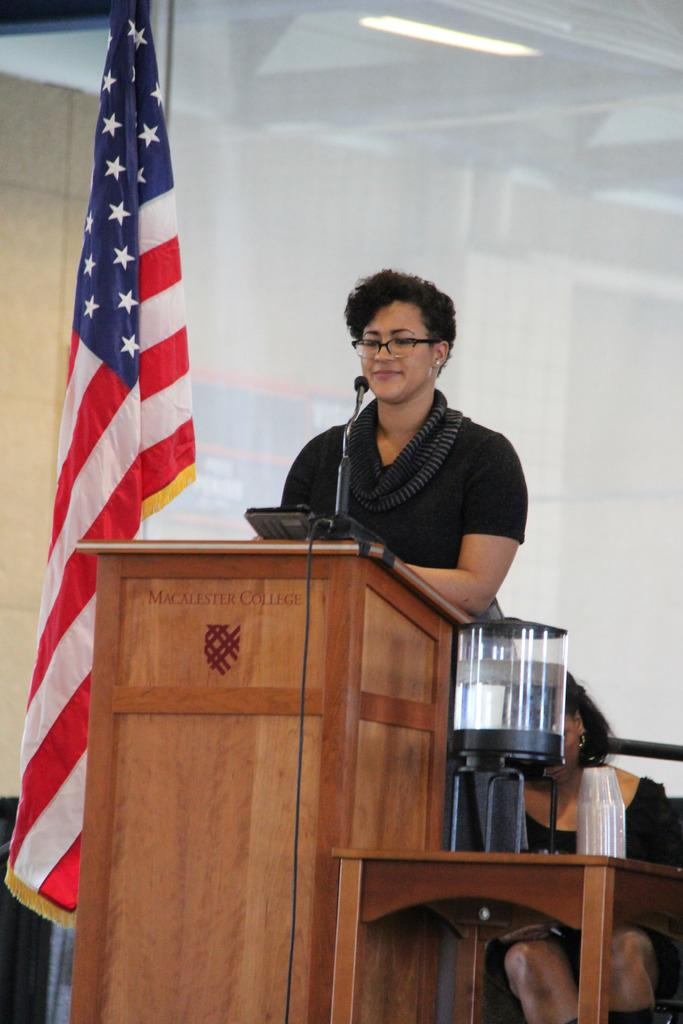<image>
Create a compact narrative representing the image presented. Woman standing behind a Macalester College podium giving a presentation. 